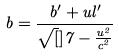Convert formula to latex. <formula><loc_0><loc_0><loc_500><loc_500>b = \frac { b ^ { \prime } + u l ^ { \prime } } { \sqrt { [ } ] { 7 - \frac { u ^ { 2 } } { c ^ { 2 } } } }</formula> 